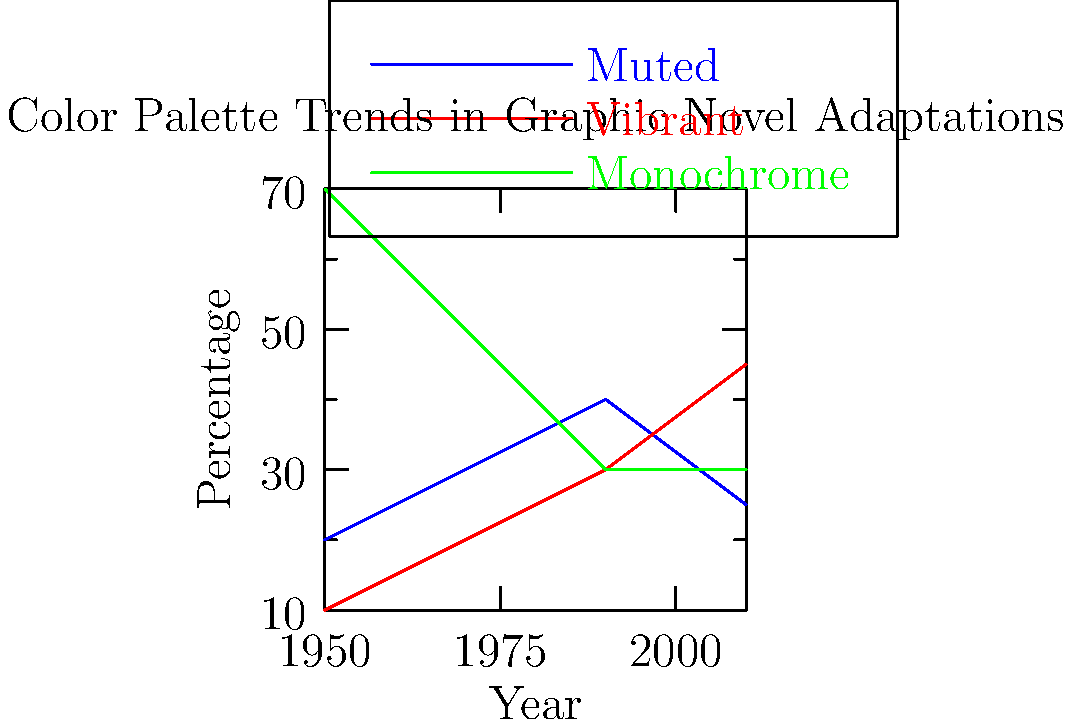Based on the graph showing color palette trends in graphic novel adaptations of classic literature, which type of color palette has shown the most significant increase from 1950 to 2010? To determine which color palette has shown the most significant increase from 1950 to 2010, we need to analyze the trends for each palette:

1. Muted palette:
   1950: 20%
   2010: 25%
   Increase: 5%

2. Vibrant palette:
   1950: 10%
   2010: 45%
   Increase: 35%

3. Monochrome palette:
   1950: 70%
   2010: 30%
   Decrease: 40%

Comparing the increases:
- Muted palette increased by 5%
- Vibrant palette increased by 35%
- Monochrome palette decreased by 40%

The vibrant palette shows the most significant increase from 1950 to 2010, with a 35% rise.
Answer: Vibrant palette 